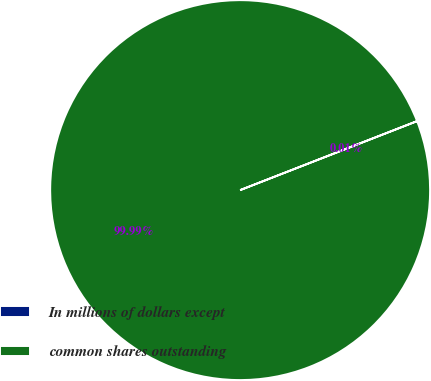Convert chart to OTSL. <chart><loc_0><loc_0><loc_500><loc_500><pie_chart><fcel>In millions of dollars except<fcel>common shares outstanding<nl><fcel>0.01%<fcel>99.99%<nl></chart> 